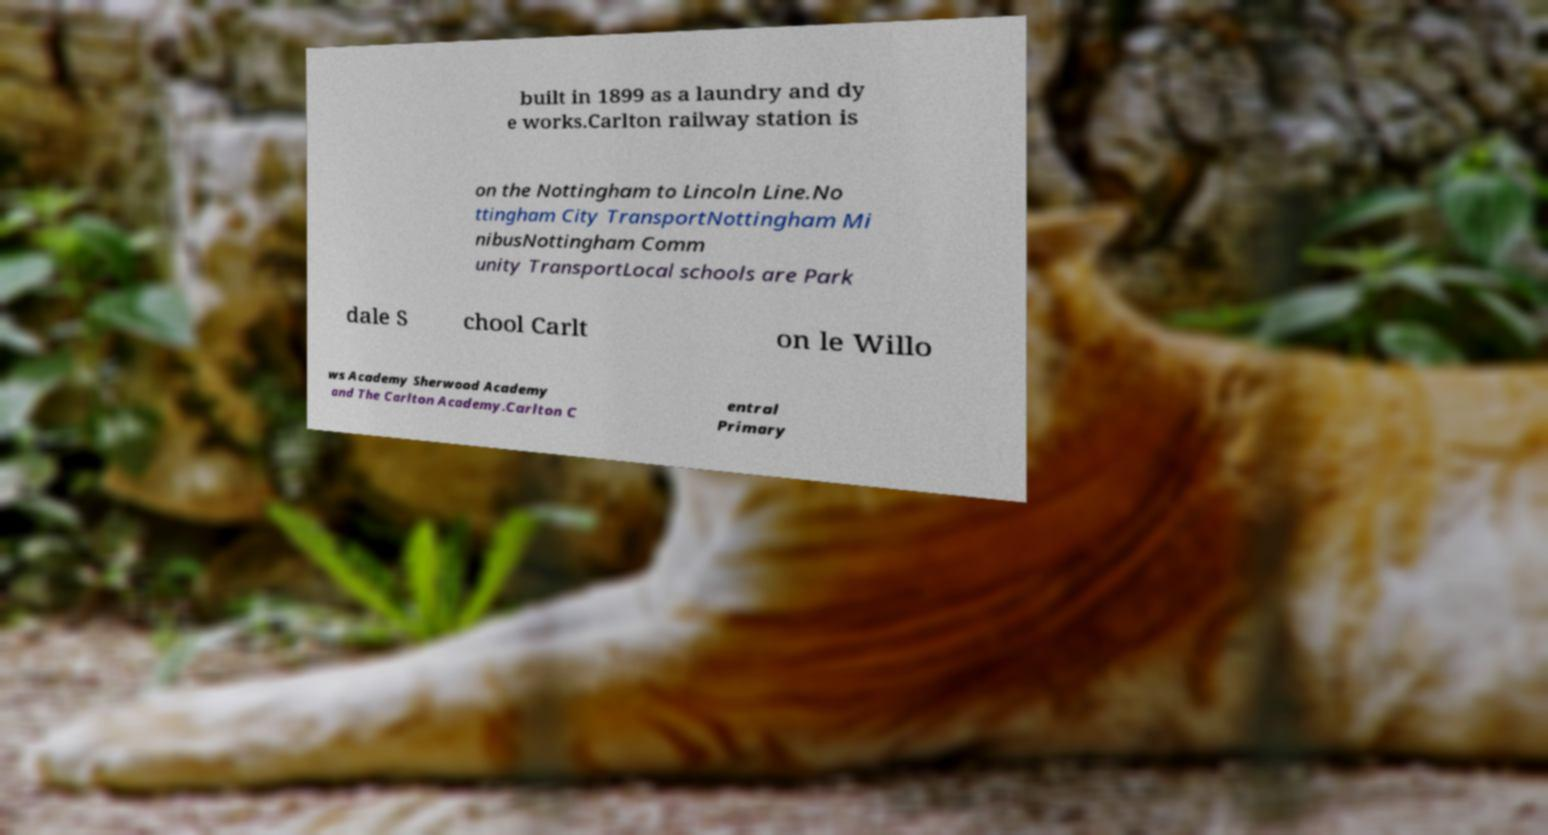Could you assist in decoding the text presented in this image and type it out clearly? built in 1899 as a laundry and dy e works.Carlton railway station is on the Nottingham to Lincoln Line.No ttingham City TransportNottingham Mi nibusNottingham Comm unity TransportLocal schools are Park dale S chool Carlt on le Willo ws Academy Sherwood Academy and The Carlton Academy.Carlton C entral Primary 